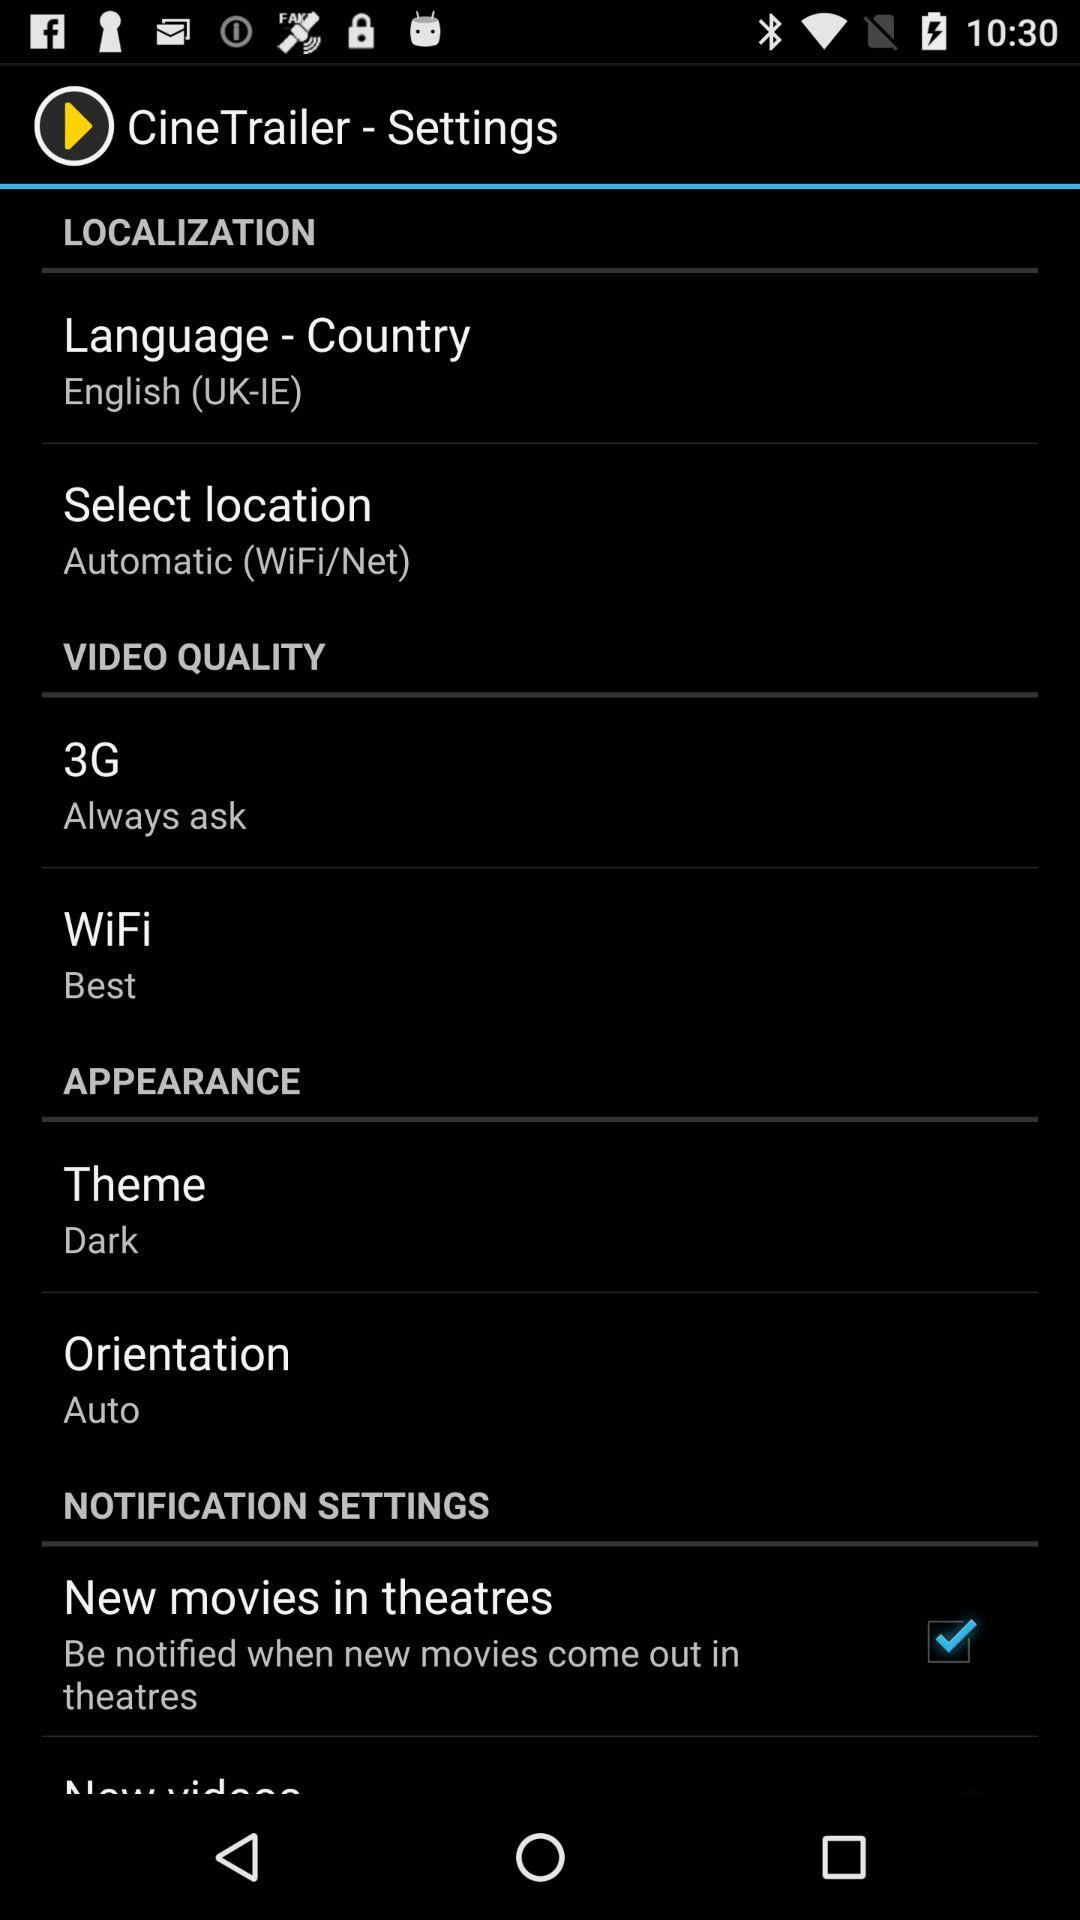What is the status of the "New movies in theatres"? The status is "on". 